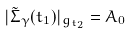Convert formula to latex. <formula><loc_0><loc_0><loc_500><loc_500>| \tilde { \Sigma } _ { \gamma } ( t _ { 1 } ) | _ { g _ { t _ { 2 } } } = A _ { 0 }</formula> 